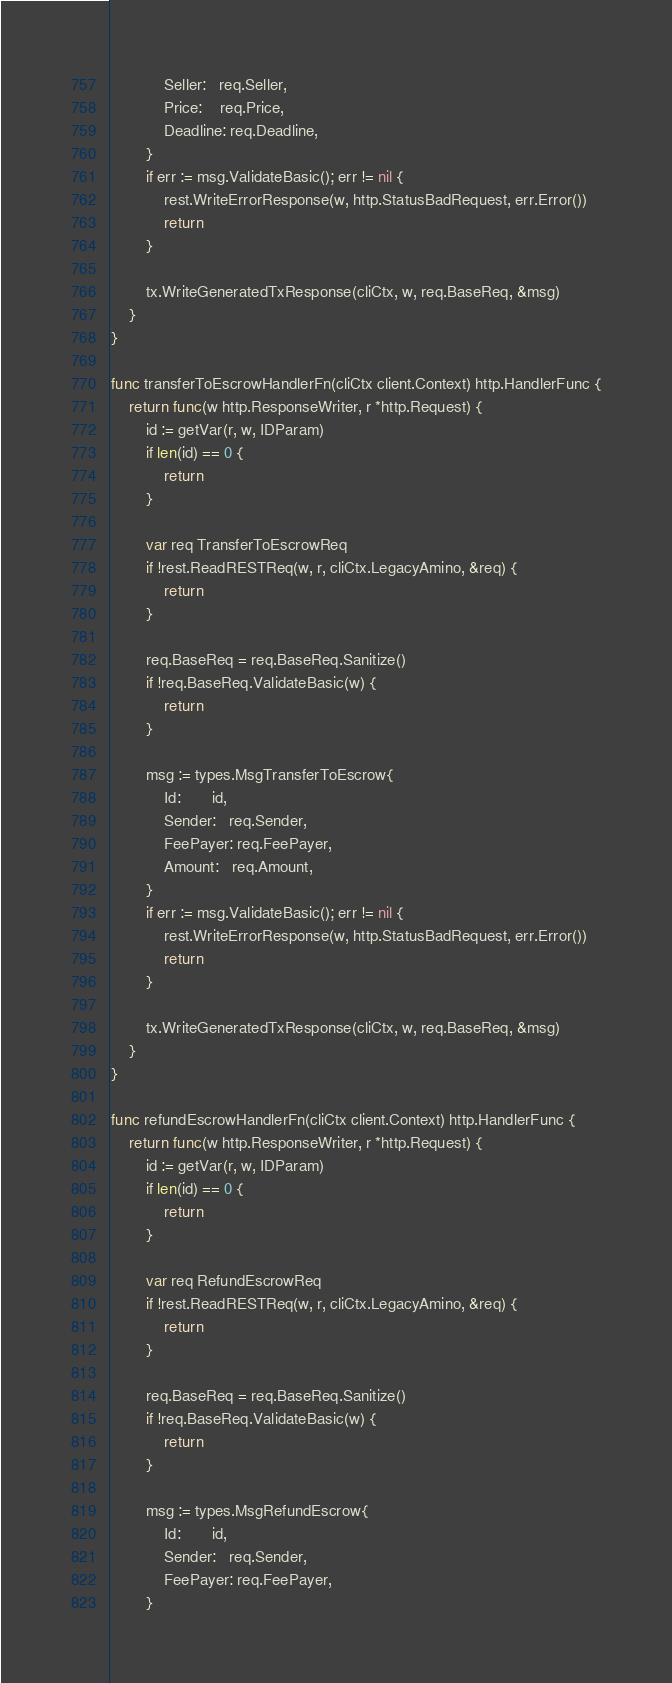<code> <loc_0><loc_0><loc_500><loc_500><_Go_>			Seller:   req.Seller,
			Price:    req.Price,
			Deadline: req.Deadline,
		}
		if err := msg.ValidateBasic(); err != nil {
			rest.WriteErrorResponse(w, http.StatusBadRequest, err.Error())
			return
		}

		tx.WriteGeneratedTxResponse(cliCtx, w, req.BaseReq, &msg)
	}
}

func transferToEscrowHandlerFn(cliCtx client.Context) http.HandlerFunc {
	return func(w http.ResponseWriter, r *http.Request) {
		id := getVar(r, w, IDParam)
		if len(id) == 0 {
			return
		}

		var req TransferToEscrowReq
		if !rest.ReadRESTReq(w, r, cliCtx.LegacyAmino, &req) {
			return
		}

		req.BaseReq = req.BaseReq.Sanitize()
		if !req.BaseReq.ValidateBasic(w) {
			return
		}

		msg := types.MsgTransferToEscrow{
			Id:       id,
			Sender:   req.Sender,
			FeePayer: req.FeePayer,
			Amount:   req.Amount,
		}
		if err := msg.ValidateBasic(); err != nil {
			rest.WriteErrorResponse(w, http.StatusBadRequest, err.Error())
			return
		}

		tx.WriteGeneratedTxResponse(cliCtx, w, req.BaseReq, &msg)
	}
}

func refundEscrowHandlerFn(cliCtx client.Context) http.HandlerFunc {
	return func(w http.ResponseWriter, r *http.Request) {
		id := getVar(r, w, IDParam)
		if len(id) == 0 {
			return
		}

		var req RefundEscrowReq
		if !rest.ReadRESTReq(w, r, cliCtx.LegacyAmino, &req) {
			return
		}

		req.BaseReq = req.BaseReq.Sanitize()
		if !req.BaseReq.ValidateBasic(w) {
			return
		}

		msg := types.MsgRefundEscrow{
			Id:       id,
			Sender:   req.Sender,
			FeePayer: req.FeePayer,
		}</code> 